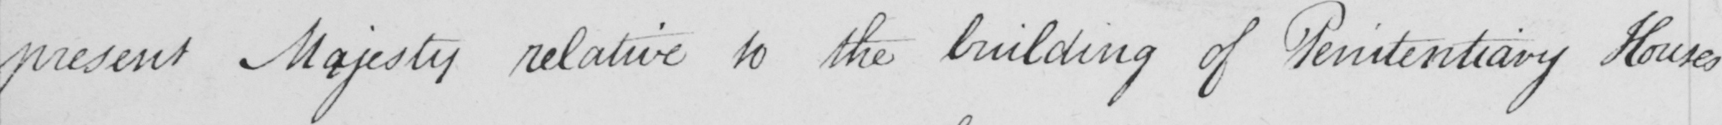Please transcribe the handwritten text in this image. present Majesty relative to the building of Penitentiary Houses 